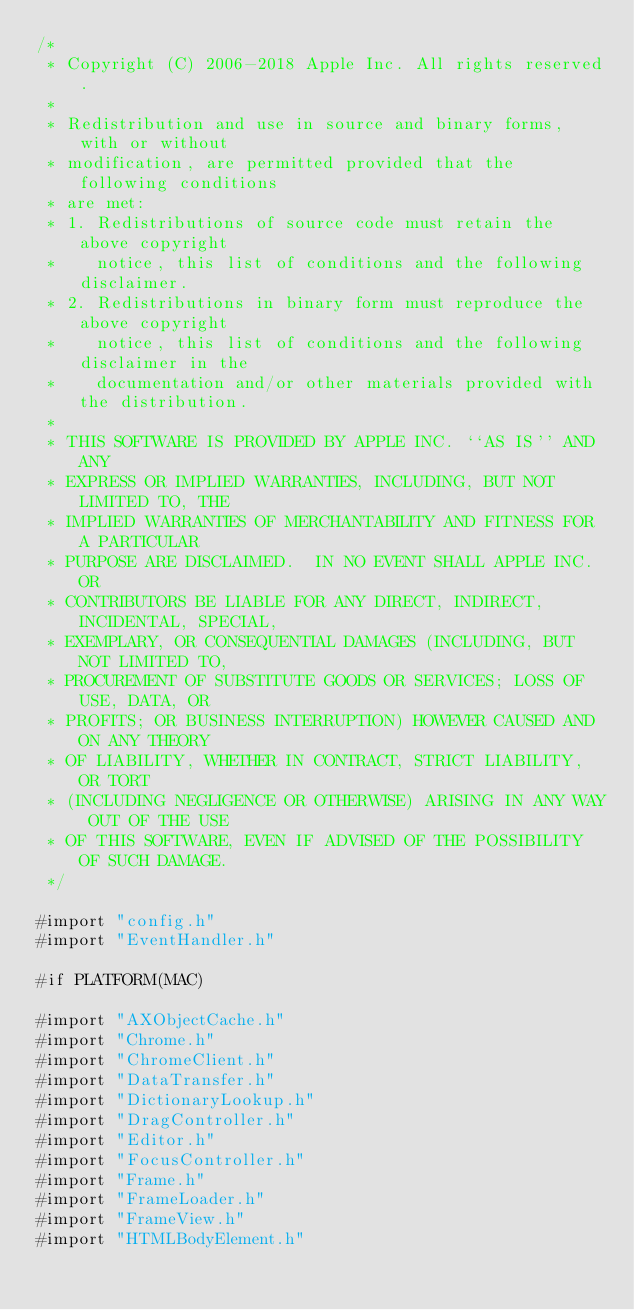Convert code to text. <code><loc_0><loc_0><loc_500><loc_500><_ObjectiveC_>/*
 * Copyright (C) 2006-2018 Apple Inc. All rights reserved.
 *
 * Redistribution and use in source and binary forms, with or without
 * modification, are permitted provided that the following conditions
 * are met:
 * 1. Redistributions of source code must retain the above copyright
 *    notice, this list of conditions and the following disclaimer.
 * 2. Redistributions in binary form must reproduce the above copyright
 *    notice, this list of conditions and the following disclaimer in the
 *    documentation and/or other materials provided with the distribution.
 *
 * THIS SOFTWARE IS PROVIDED BY APPLE INC. ``AS IS'' AND ANY
 * EXPRESS OR IMPLIED WARRANTIES, INCLUDING, BUT NOT LIMITED TO, THE
 * IMPLIED WARRANTIES OF MERCHANTABILITY AND FITNESS FOR A PARTICULAR
 * PURPOSE ARE DISCLAIMED.  IN NO EVENT SHALL APPLE INC. OR
 * CONTRIBUTORS BE LIABLE FOR ANY DIRECT, INDIRECT, INCIDENTAL, SPECIAL,
 * EXEMPLARY, OR CONSEQUENTIAL DAMAGES (INCLUDING, BUT NOT LIMITED TO,
 * PROCUREMENT OF SUBSTITUTE GOODS OR SERVICES; LOSS OF USE, DATA, OR
 * PROFITS; OR BUSINESS INTERRUPTION) HOWEVER CAUSED AND ON ANY THEORY
 * OF LIABILITY, WHETHER IN CONTRACT, STRICT LIABILITY, OR TORT
 * (INCLUDING NEGLIGENCE OR OTHERWISE) ARISING IN ANY WAY OUT OF THE USE
 * OF THIS SOFTWARE, EVEN IF ADVISED OF THE POSSIBILITY OF SUCH DAMAGE. 
 */

#import "config.h"
#import "EventHandler.h"

#if PLATFORM(MAC)

#import "AXObjectCache.h"
#import "Chrome.h"
#import "ChromeClient.h"
#import "DataTransfer.h"
#import "DictionaryLookup.h"
#import "DragController.h"
#import "Editor.h"
#import "FocusController.h"
#import "Frame.h"
#import "FrameLoader.h"
#import "FrameView.h"
#import "HTMLBodyElement.h"</code> 